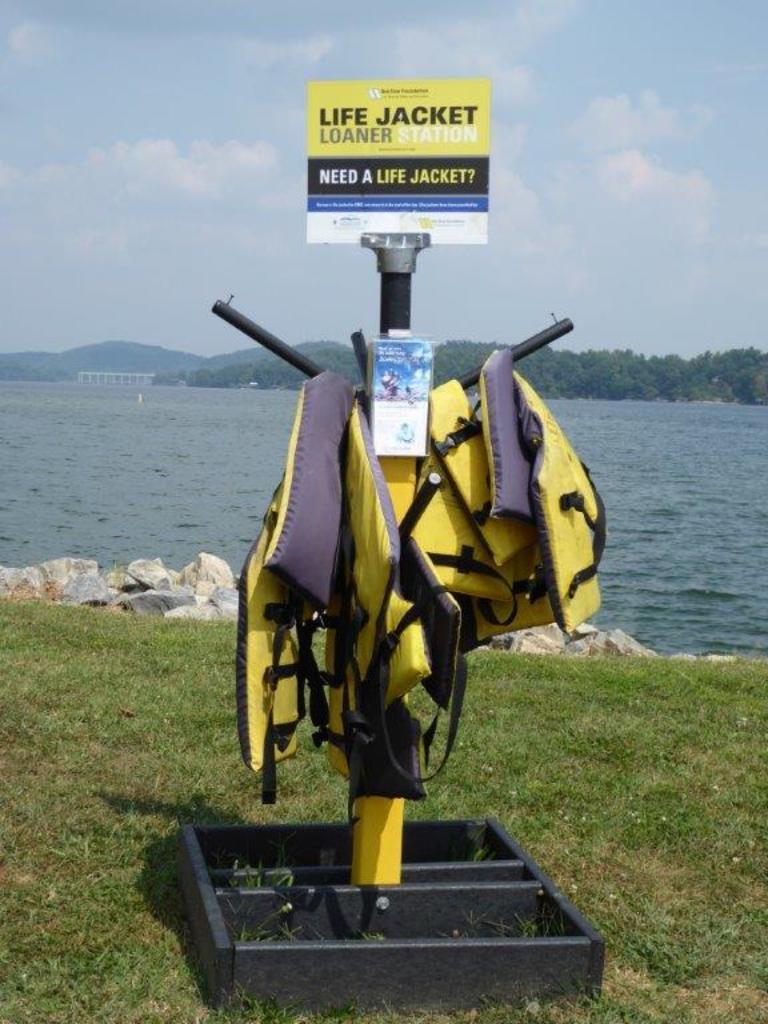In one or two sentences, can you explain what this image depicts? Here we see a lake,clouds and few trees at the back and a stand which is holding jackets. 